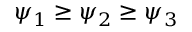Convert formula to latex. <formula><loc_0><loc_0><loc_500><loc_500>\psi _ { 1 } \geq \psi _ { 2 } \geq \psi _ { 3 }</formula> 